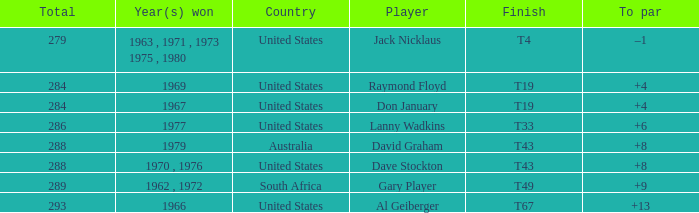What is the average total in 1969? 284.0. 